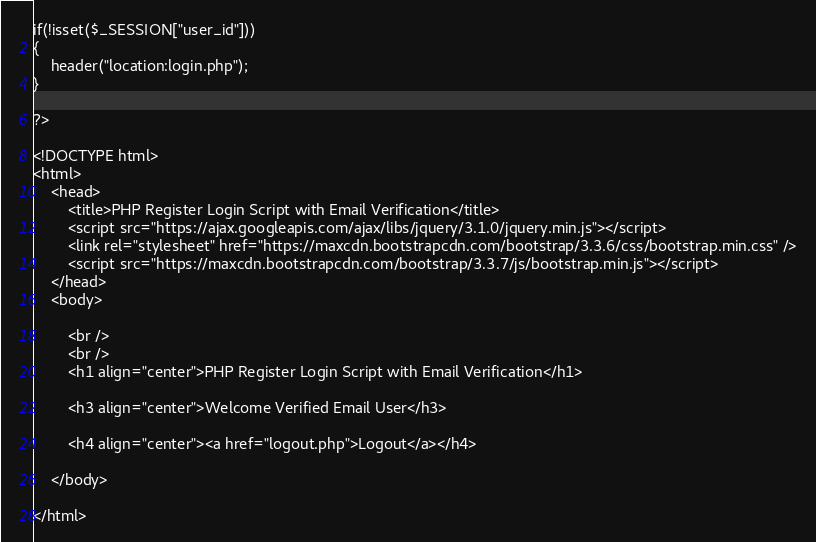Convert code to text. <code><loc_0><loc_0><loc_500><loc_500><_PHP_>
if(!isset($_SESSION["user_id"]))
{
	header("location:login.php");
}

?>

<!DOCTYPE html>
<html>
	<head>
		<title>PHP Register Login Script with Email Verification</title>		
		<script src="https://ajax.googleapis.com/ajax/libs/jquery/3.1.0/jquery.min.js"></script>
		<link rel="stylesheet" href="https://maxcdn.bootstrapcdn.com/bootstrap/3.3.6/css/bootstrap.min.css" />
		<script src="https://maxcdn.bootstrapcdn.com/bootstrap/3.3.7/js/bootstrap.min.js"></script>
	</head>
	<body>
		
		<br />
		<br />
		<h1 align="center">PHP Register Login Script with Email Verification</h1>
		
		<h3 align="center">Welcome Verified Email User</h3>
		
		<h4 align="center"><a href="logout.php">Logout</a></h4>
	
	</body>
	
</html>

</code> 